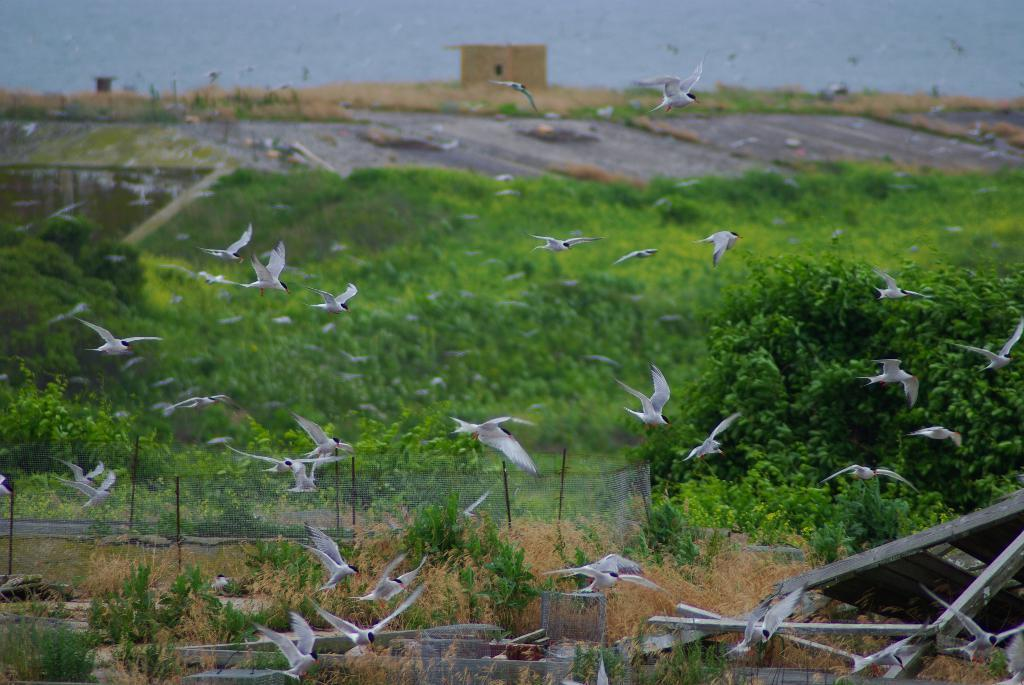What is happening in the image? There are many birds flying in the image. What can be seen in the background of the image? There are trees, plants, fencing, a shed, and the sky visible in the background of the image. What type of cloth is being distributed by the birds in the image? There is no cloth being distributed by the birds in the image; they are simply flying. Can you see a car in the image? There is no car present in the image. 